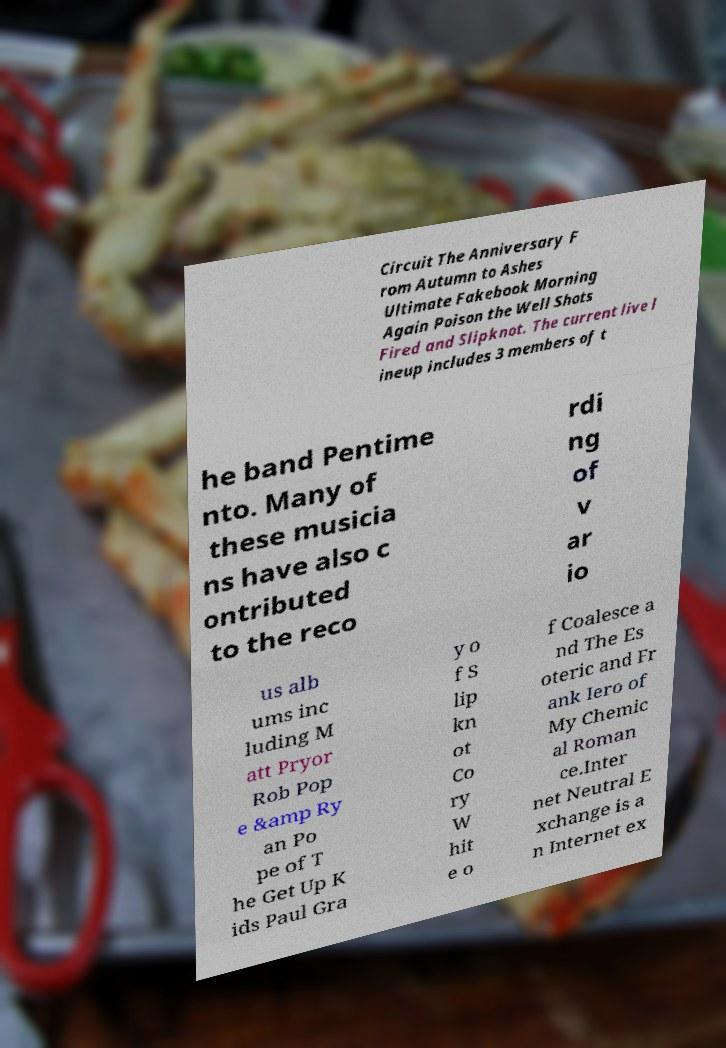I need the written content from this picture converted into text. Can you do that? Circuit The Anniversary F rom Autumn to Ashes Ultimate Fakebook Morning Again Poison the Well Shots Fired and Slipknot. The current live l ineup includes 3 members of t he band Pentime nto. Many of these musicia ns have also c ontributed to the reco rdi ng of v ar io us alb ums inc luding M att Pryor Rob Pop e &amp Ry an Po pe of T he Get Up K ids Paul Gra y o f S lip kn ot Co ry W hit e o f Coalesce a nd The Es oteric and Fr ank Iero of My Chemic al Roman ce.Inter net Neutral E xchange is a n Internet ex 